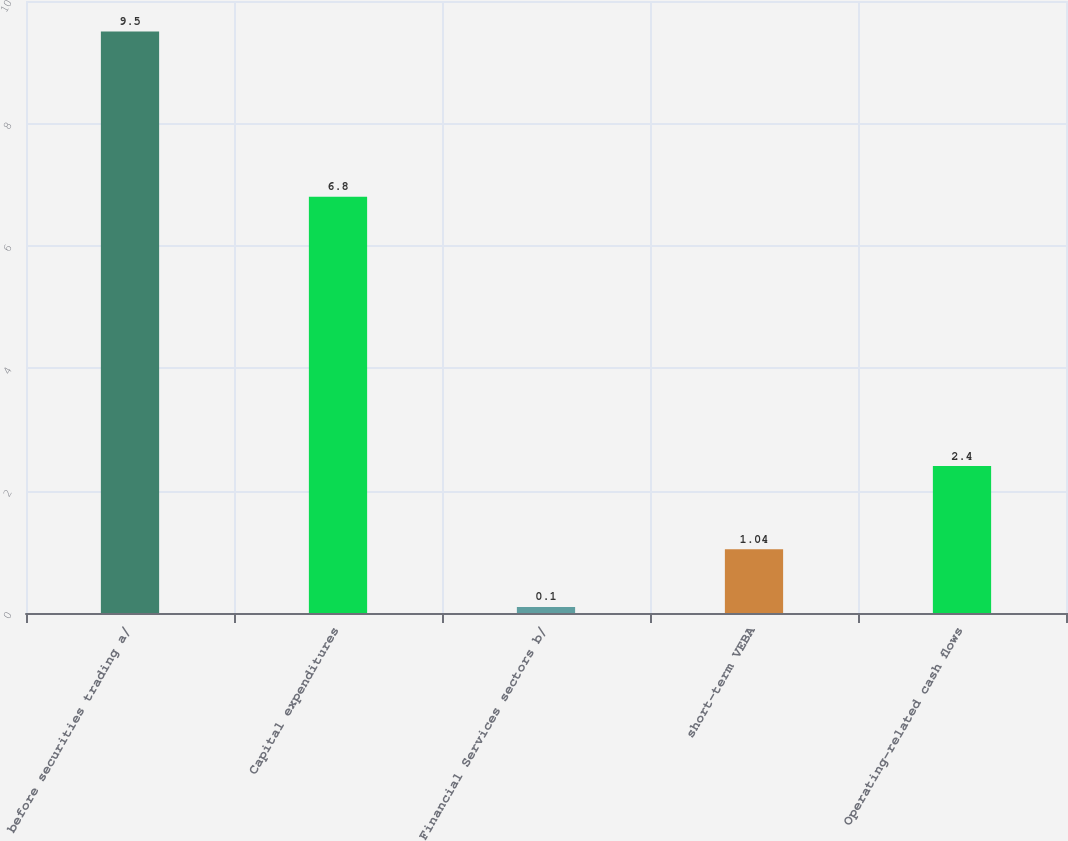<chart> <loc_0><loc_0><loc_500><loc_500><bar_chart><fcel>before securities trading a/<fcel>Capital expenditures<fcel>Financial Services sectors b/<fcel>short-term VEBA<fcel>Operating-related cash flows<nl><fcel>9.5<fcel>6.8<fcel>0.1<fcel>1.04<fcel>2.4<nl></chart> 